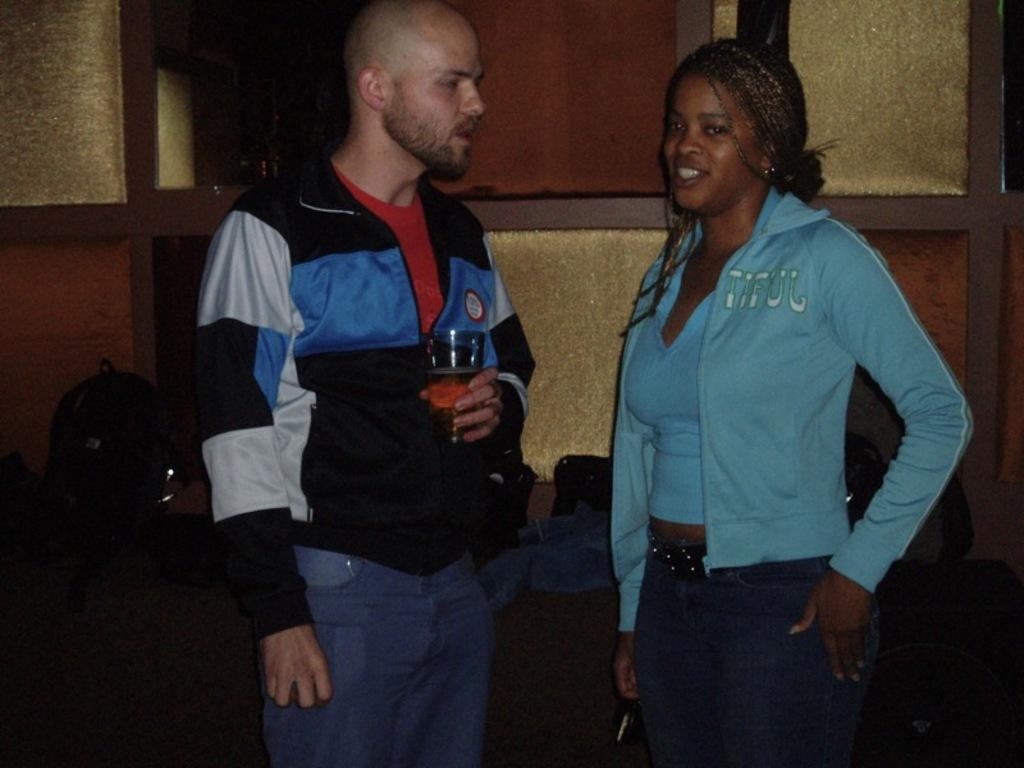What is the man in the image doing with his hand? The man is holding a glass with his hand. How is the woman in the image feeling? The woman is smiling. What can be seen in the background of the image? There is a bag, a wall, and some objects in the background of the image. How many rabbits can be seen playing on the table in the image? There are no rabbits or tables present in the image. What type of airport can be seen in the background of the image? There is no airport visible in the image; it features a man, a woman, and objects in the background. 